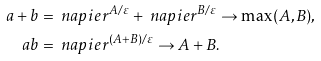Convert formula to latex. <formula><loc_0><loc_0><loc_500><loc_500>a + b & = \ n a p i e r ^ { A / \varepsilon } + \ n a p i e r ^ { B / \varepsilon } \to \max ( A , B ) , \\ a b & = \ n a p i e r ^ { ( A + B ) / \varepsilon } \to A + B .</formula> 